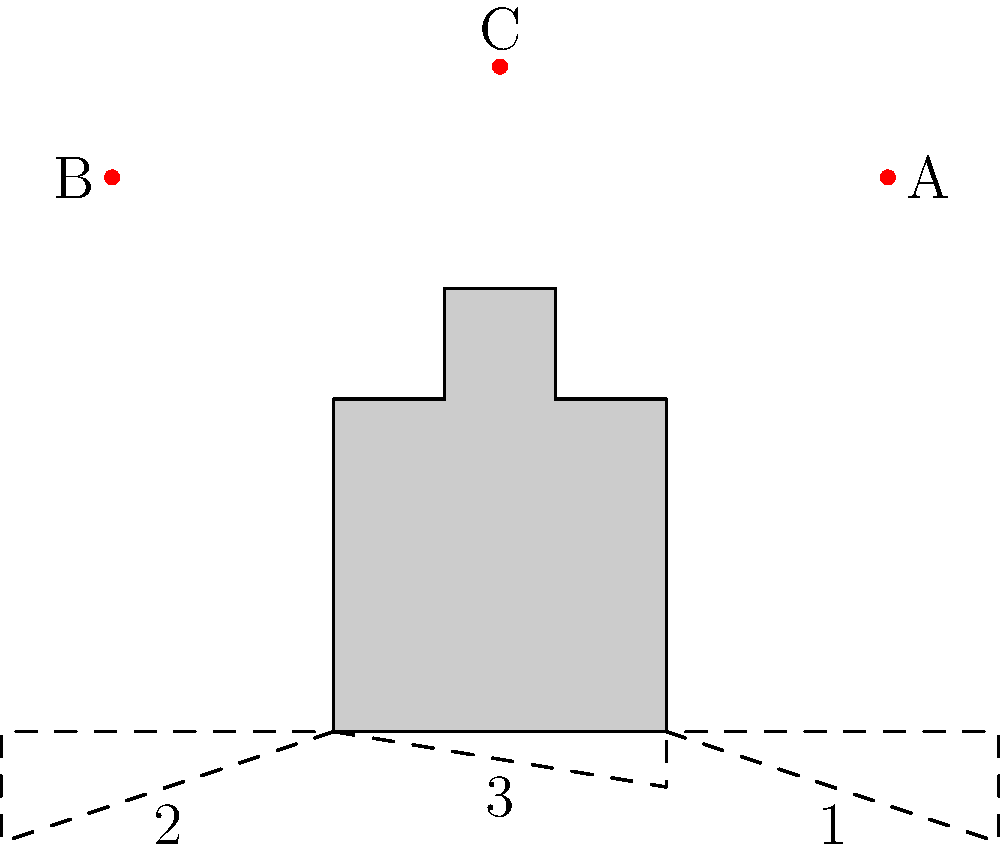As the sun moves across the sky, the shadow cast by the castle turret changes. Which shadow (1, 2, or 3) corresponds to the sun's position at point B? To determine the correct shadow, we need to follow these steps:

1. Understand the relationship between the sun's position and shadow direction:
   - Shadows are cast in the opposite direction from the light source.
   - The shadow's length depends on the sun's height in the sky.

2. Analyze the sun's position at point B:
   - Point B is located to the left (west) of the turret.
   - This means the sun is shining from the left side.

3. Examine the shadow options:
   - Shadow 1 extends to the right, indicating sunlight from the left.
   - Shadow 2 extends to the left, indicating sunlight from the right.
   - Shadow 3 is short and centered, indicating sunlight from directly above.

4. Match the sun's position with the correct shadow:
   - Since the sun at point B is shining from the left side, the shadow should extend to the right.
   - This corresponds to shadow 1 in the diagram.

5. Consider the shadow's length:
   - The sun at point B is relatively low in the sky (not directly overhead).
   - This would create a longer shadow, which is consistent with shadow 1.

Therefore, the shadow that corresponds to the sun's position at point B is shadow 1.
Answer: 1 